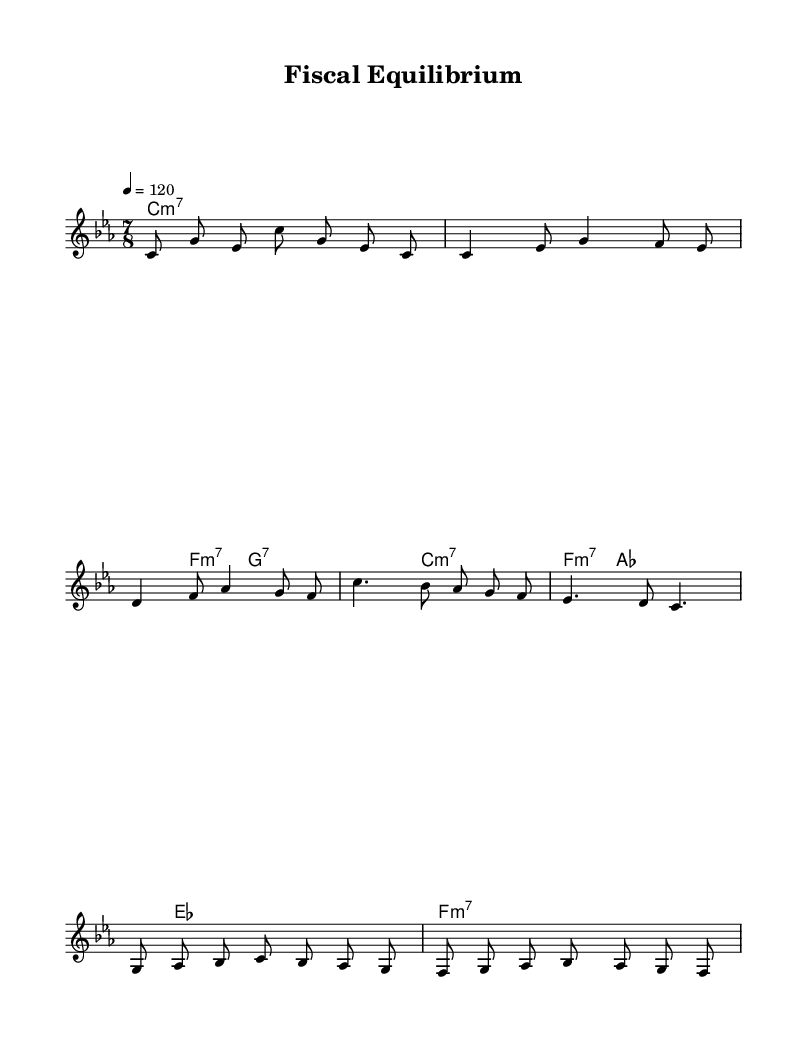What is the key signature of this music? The key signature is C minor, which has three flats (B, E, and A). This can be identified by looking at the initial clef and checking the flat symbols placed on the staff, indicating the key of C minor.
Answer: C minor What is the time signature of the piece? The time signature is 7/8, which is displayed at the beginning of the score. This indicates that there are seven beats in each measure and that the eighth note gets one beat.
Answer: 7/8 What is the tempo marking for the composition? The tempo marking is 120, indicated in quarter note beats per minute. This gives the performer a guide for the speed of the piece, which is noted just below the time signature at the beginning of the score.
Answer: 120 How many measures are there in the melody section? The melody section includes a total of 10 measures. This can be counted by looking at the vertical bar lines that separate each measure throughout the melody part.
Answer: 10 What type of chords are predominantly used in the harmony section? The harmony section predominantly uses minor seventh chords, as indicated by the "m7" notation next to the chord names, which signifies that the chords are minor and include an added minor seventh interval.
Answer: Minor seventh What is the longest note value present in the score? The longest note value present in the score is a whole note, found in the harmonic section where chord symbols are provided, like in the introduction. The note is held for the duration of four beats.
Answer: Whole note 